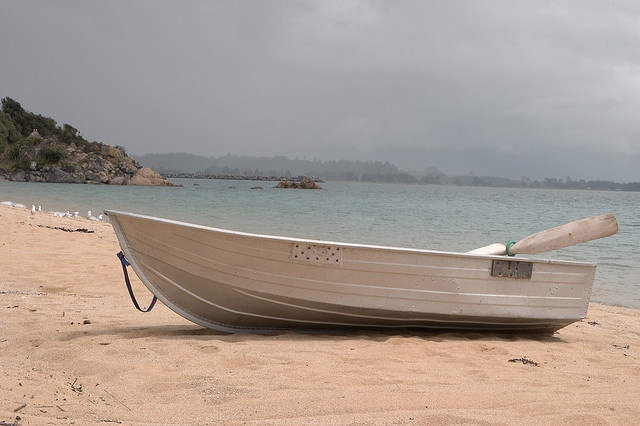Describe the objects in this image and their specific colors. I can see boat in darkgray and gray tones, bird in darkgray, lightgray, and tan tones, bird in darkgray, lightgray, and gray tones, bird in darkgray, lightgray, tan, and gray tones, and bird in darkgray, lightgray, and gray tones in this image. 